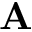Convert formula to latex. <formula><loc_0><loc_0><loc_500><loc_500>A</formula> 